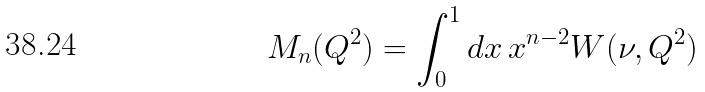<formula> <loc_0><loc_0><loc_500><loc_500>M _ { n } ( Q ^ { 2 } ) = \int _ { 0 } ^ { 1 } d x \, x ^ { n - 2 } W ( \nu , Q ^ { 2 } )</formula> 